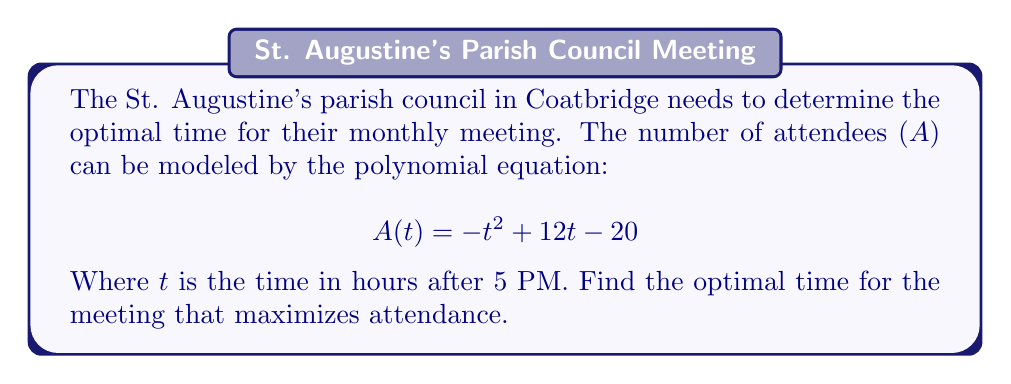Give your solution to this math problem. To find the optimal time, we need to determine the maximum value of the quadratic function A(t).

1) The quadratic function $A(t) = -t^2 + 12t - 20$ is in the form $f(t) = a(t-h)^2 + k$, where (h,k) is the vertex.

2) For a quadratic function $f(t) = at^2 + bt + c$, the t-coordinate of the vertex is given by $t = -\frac{b}{2a}$.

3) In this case, $a = -1$ and $b = 12$. So:

   $t = -\frac{12}{2(-1)} = -\frac{12}{-2} = 6$

4) This means the optimal time is 6 hours after 5 PM, which is 11 PM.

5) To verify, we can substitute values around t = 6 into the original equation:

   $A(5) = -(5)^2 + 12(5) - 20 = -25 + 60 - 20 = 15$
   $A(6) = -(6)^2 + 12(6) - 20 = -36 + 72 - 20 = 16$
   $A(7) = -(7)^2 + 12(7) - 20 = -49 + 84 - 20 = 15$

   This confirms that attendance is highest at t = 6.
Answer: 11 PM 